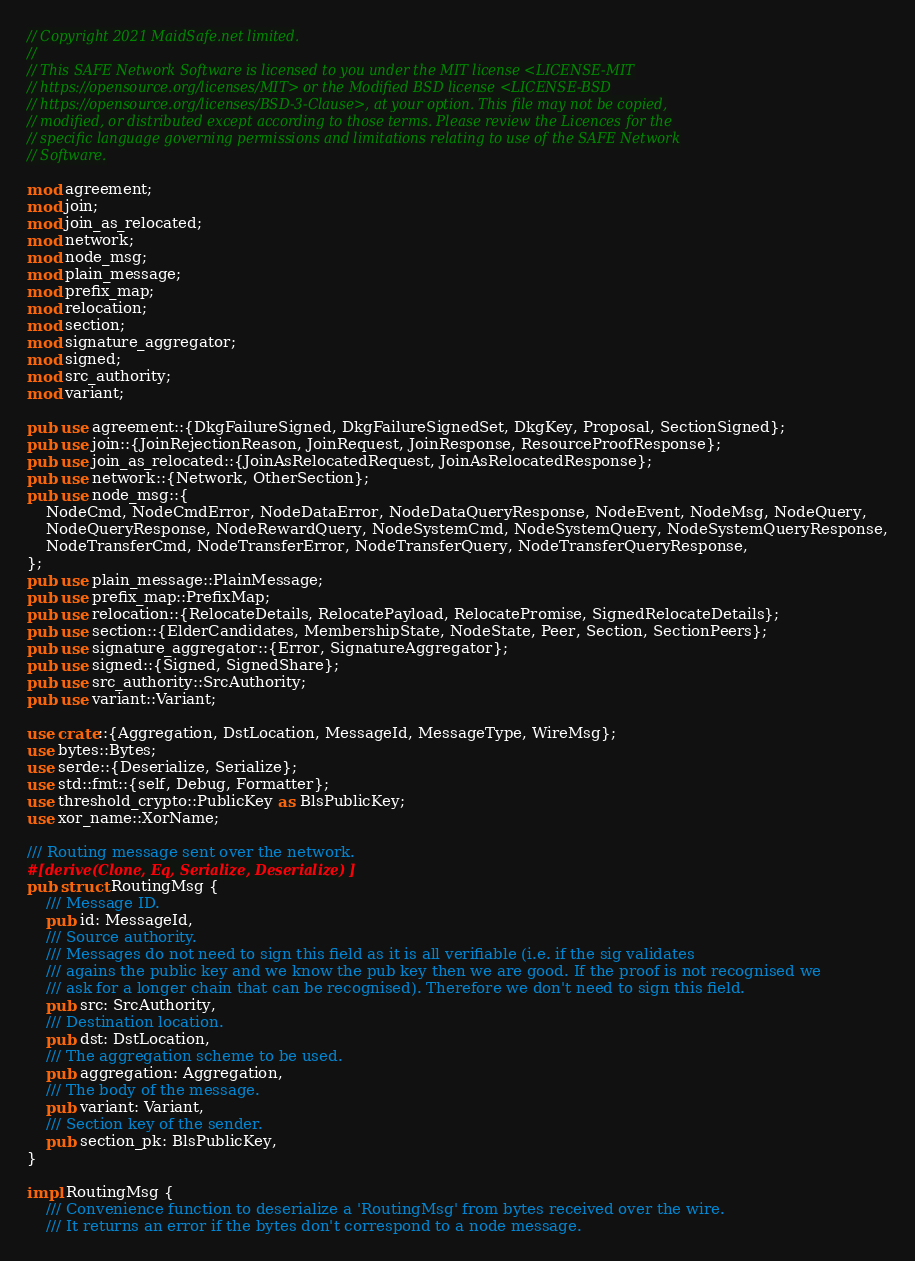<code> <loc_0><loc_0><loc_500><loc_500><_Rust_>// Copyright 2021 MaidSafe.net limited.
//
// This SAFE Network Software is licensed to you under the MIT license <LICENSE-MIT
// https://opensource.org/licenses/MIT> or the Modified BSD license <LICENSE-BSD
// https://opensource.org/licenses/BSD-3-Clause>, at your option. This file may not be copied,
// modified, or distributed except according to those terms. Please review the Licences for the
// specific language governing permissions and limitations relating to use of the SAFE Network
// Software.

mod agreement;
mod join;
mod join_as_relocated;
mod network;
mod node_msg;
mod plain_message;
mod prefix_map;
mod relocation;
mod section;
mod signature_aggregator;
mod signed;
mod src_authority;
mod variant;

pub use agreement::{DkgFailureSigned, DkgFailureSignedSet, DkgKey, Proposal, SectionSigned};
pub use join::{JoinRejectionReason, JoinRequest, JoinResponse, ResourceProofResponse};
pub use join_as_relocated::{JoinAsRelocatedRequest, JoinAsRelocatedResponse};
pub use network::{Network, OtherSection};
pub use node_msg::{
    NodeCmd, NodeCmdError, NodeDataError, NodeDataQueryResponse, NodeEvent, NodeMsg, NodeQuery,
    NodeQueryResponse, NodeRewardQuery, NodeSystemCmd, NodeSystemQuery, NodeSystemQueryResponse,
    NodeTransferCmd, NodeTransferError, NodeTransferQuery, NodeTransferQueryResponse,
};
pub use plain_message::PlainMessage;
pub use prefix_map::PrefixMap;
pub use relocation::{RelocateDetails, RelocatePayload, RelocatePromise, SignedRelocateDetails};
pub use section::{ElderCandidates, MembershipState, NodeState, Peer, Section, SectionPeers};
pub use signature_aggregator::{Error, SignatureAggregator};
pub use signed::{Signed, SignedShare};
pub use src_authority::SrcAuthority;
pub use variant::Variant;

use crate::{Aggregation, DstLocation, MessageId, MessageType, WireMsg};
use bytes::Bytes;
use serde::{Deserialize, Serialize};
use std::fmt::{self, Debug, Formatter};
use threshold_crypto::PublicKey as BlsPublicKey;
use xor_name::XorName;

/// Routing message sent over the network.
#[derive(Clone, Eq, Serialize, Deserialize)]
pub struct RoutingMsg {
    /// Message ID.
    pub id: MessageId,
    /// Source authority.
    /// Messages do not need to sign this field as it is all verifiable (i.e. if the sig validates
    /// agains the public key and we know the pub key then we are good. If the proof is not recognised we
    /// ask for a longer chain that can be recognised). Therefore we don't need to sign this field.
    pub src: SrcAuthority,
    /// Destination location.
    pub dst: DstLocation,
    /// The aggregation scheme to be used.
    pub aggregation: Aggregation,
    /// The body of the message.
    pub variant: Variant,
    /// Section key of the sender.
    pub section_pk: BlsPublicKey,
}

impl RoutingMsg {
    /// Convenience function to deserialize a 'RoutingMsg' from bytes received over the wire.
    /// It returns an error if the bytes don't correspond to a node message.</code> 